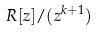<formula> <loc_0><loc_0><loc_500><loc_500>R [ z ] / ( z ^ { k + 1 } )</formula> 